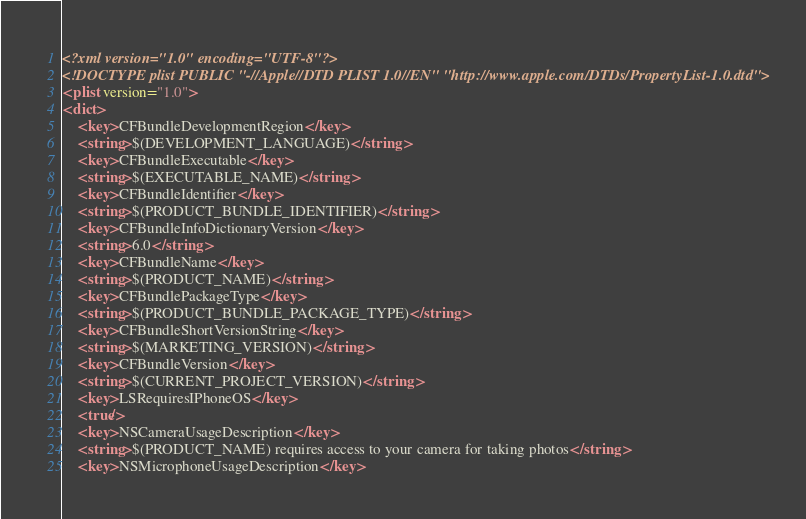Convert code to text. <code><loc_0><loc_0><loc_500><loc_500><_XML_><?xml version="1.0" encoding="UTF-8"?>
<!DOCTYPE plist PUBLIC "-//Apple//DTD PLIST 1.0//EN" "http://www.apple.com/DTDs/PropertyList-1.0.dtd">
<plist version="1.0">
<dict>
	<key>CFBundleDevelopmentRegion</key>
	<string>$(DEVELOPMENT_LANGUAGE)</string>
	<key>CFBundleExecutable</key>
	<string>$(EXECUTABLE_NAME)</string>
	<key>CFBundleIdentifier</key>
	<string>$(PRODUCT_BUNDLE_IDENTIFIER)</string>
	<key>CFBundleInfoDictionaryVersion</key>
	<string>6.0</string>
	<key>CFBundleName</key>
	<string>$(PRODUCT_NAME)</string>
	<key>CFBundlePackageType</key>
	<string>$(PRODUCT_BUNDLE_PACKAGE_TYPE)</string>
	<key>CFBundleShortVersionString</key>
	<string>$(MARKETING_VERSION)</string>
	<key>CFBundleVersion</key>
	<string>$(CURRENT_PROJECT_VERSION)</string>
	<key>LSRequiresIPhoneOS</key>
	<true/>
	<key>NSCameraUsageDescription</key>
	<string>$(PRODUCT_NAME) requires access to your camera for taking photos</string>
	<key>NSMicrophoneUsageDescription</key></code> 